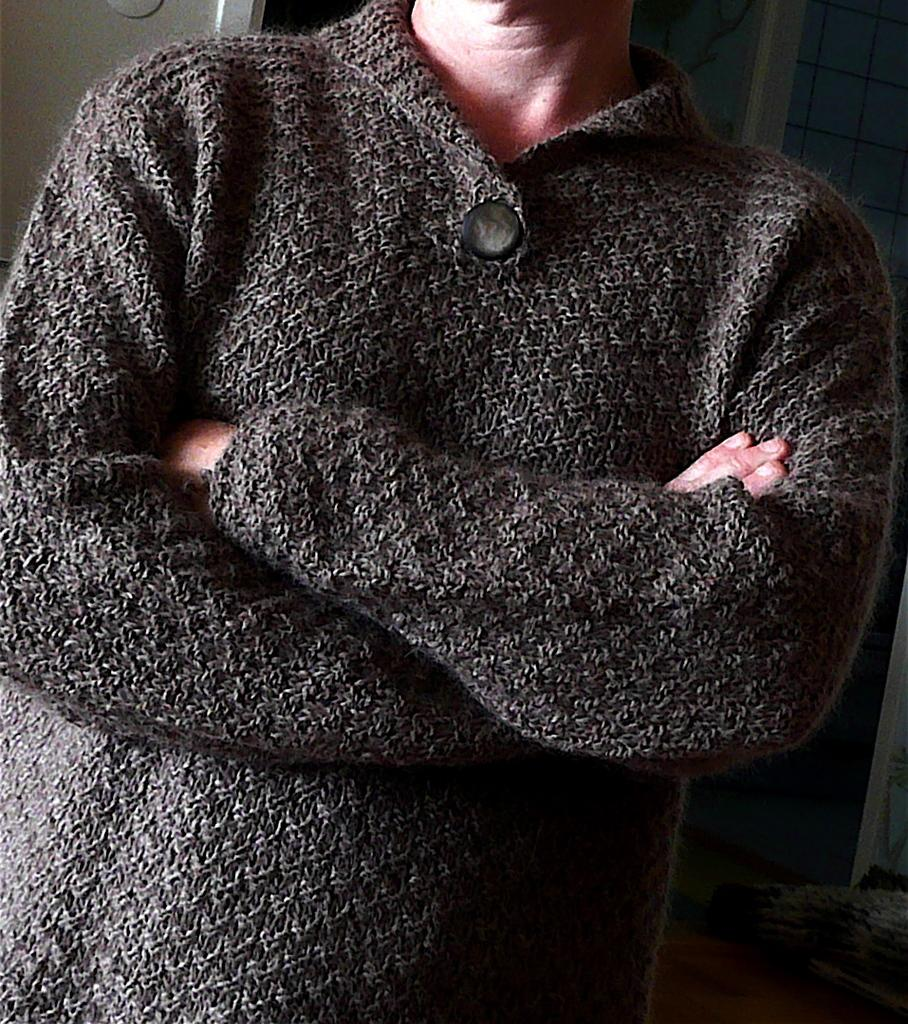What is the main subject of the image? There is a person standing in the image. What is the person wearing in the image? The person is wearing a gray color shirt. What can be seen in the background of the image? The background of the image includes a wall. What color is the wall in the image? The wall is in cream color. What type of fruit is the person holding in the image? There is no fruit present in the image; the person is not holding any fruit. How does the person's ear look like in the image? The image does not show the person's ear, so it cannot be described. 